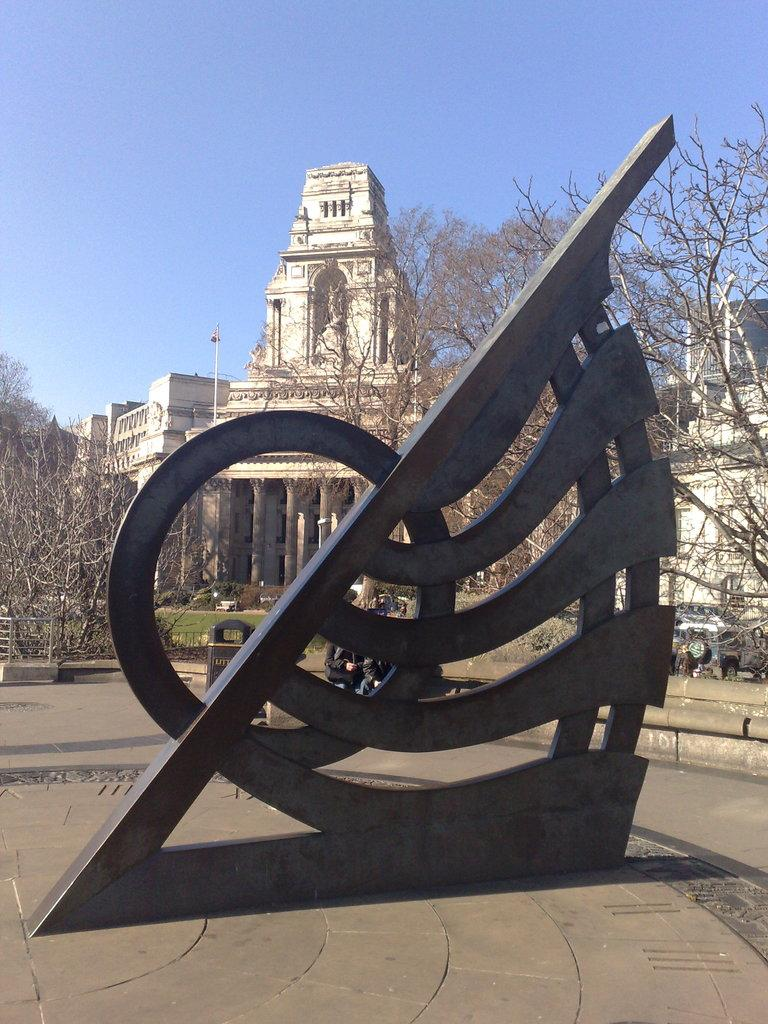What type of structures can be seen in the image? There are buildings in the image. What architectural elements are present in the image? There are pillars in the image. What type of vegetation is present in the image? Dry trees are present in the image. What mode of transportation can be seen in the image? Vehicles are visible in the image. What object is used for waste disposal in the image? A dustbin is in the image. What activity are people engaged in within the image? There are people sitting in the image. What is the color of the blue and black object in the image? The blue and black object in the image has a blue color. What is the color of the sky in the image? The sky is blue in color. Can you tell me how many potatoes are being talked about in the image? There are no potatoes or any discussion about potatoes in the image. What type of board is being used by the people sitting in the image? There is no board present in the image; people are simply sitting. 